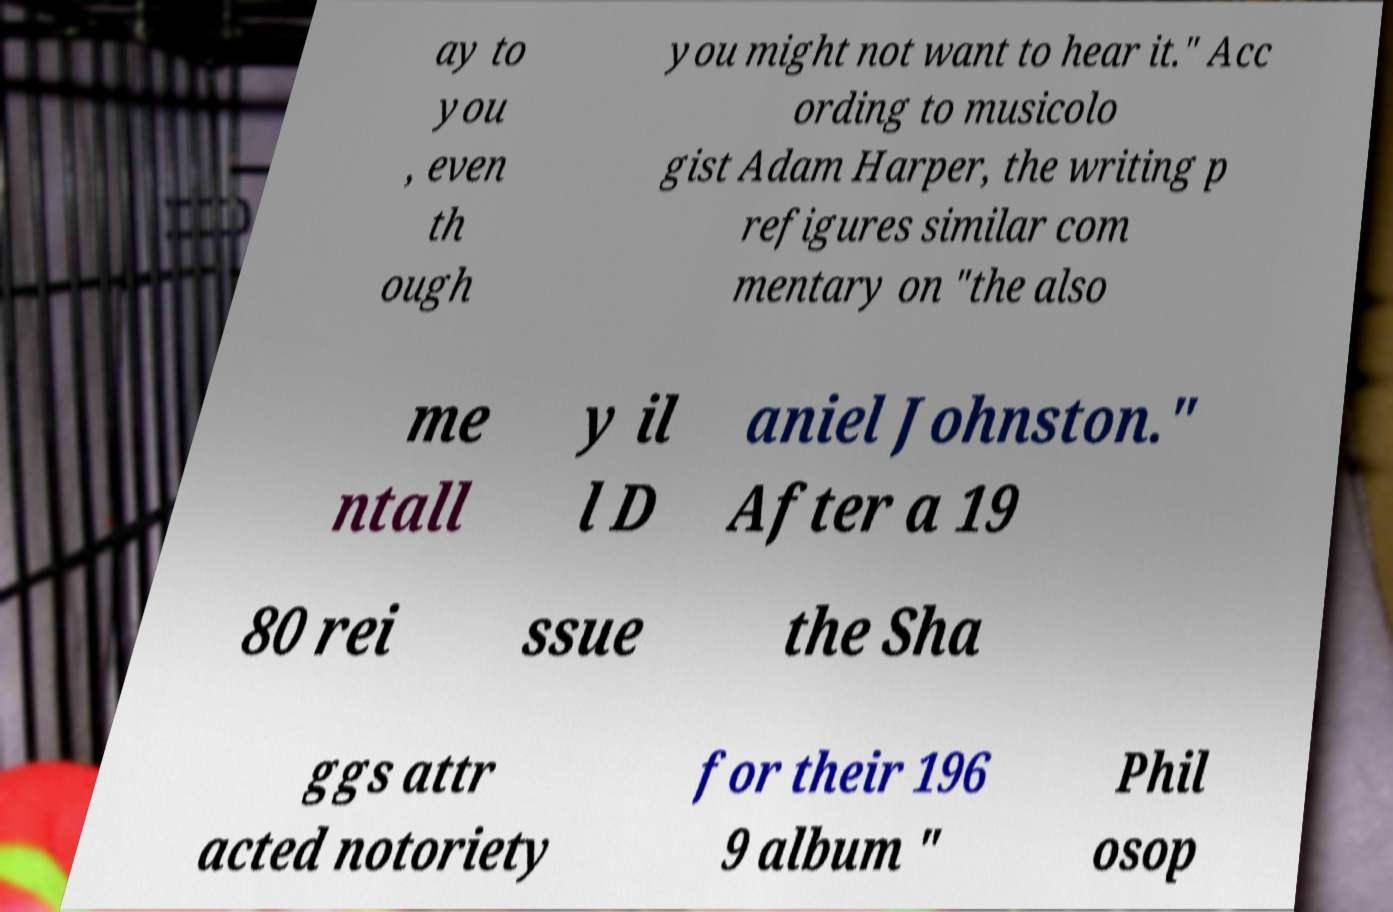Could you extract and type out the text from this image? ay to you , even th ough you might not want to hear it." Acc ording to musicolo gist Adam Harper, the writing p refigures similar com mentary on "the also me ntall y il l D aniel Johnston." After a 19 80 rei ssue the Sha ggs attr acted notoriety for their 196 9 album " Phil osop 